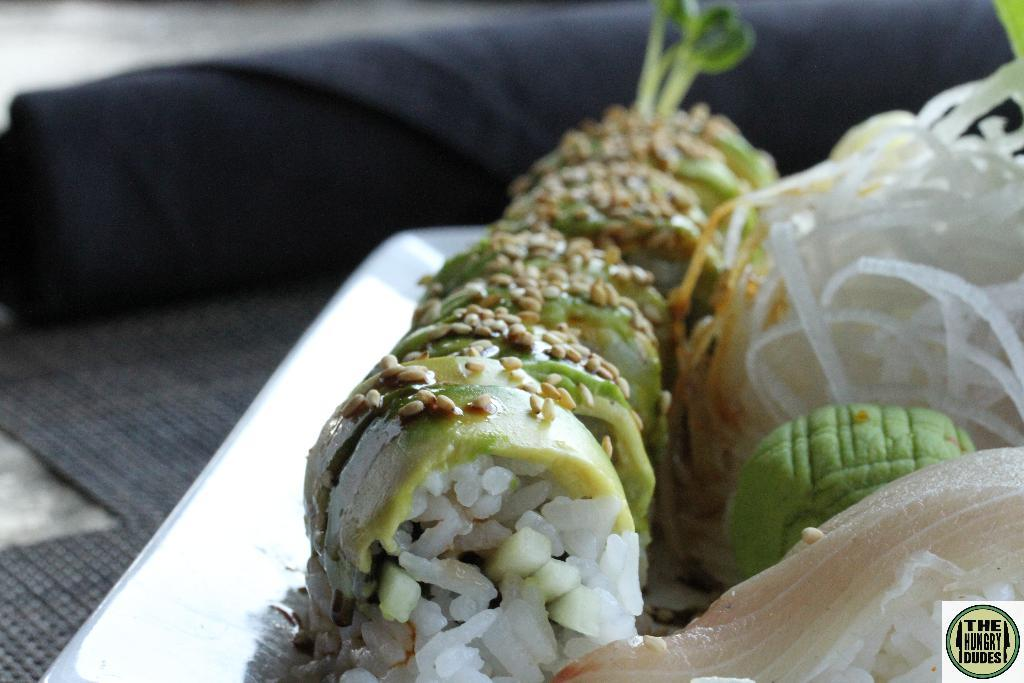What is on the tray that is visible in the image? There are food items on a tray in the image. Where is the tray located in the image? The tray is placed on a platform. What can be seen in the background of the image? There is an object visible in the background of the image. What is present in the bottom right corner of the image? There is text present in the bottom right corner of the image. What type of drum can be heard playing in the image? There is no drum present in the image, and therefore no sound can be heard. 